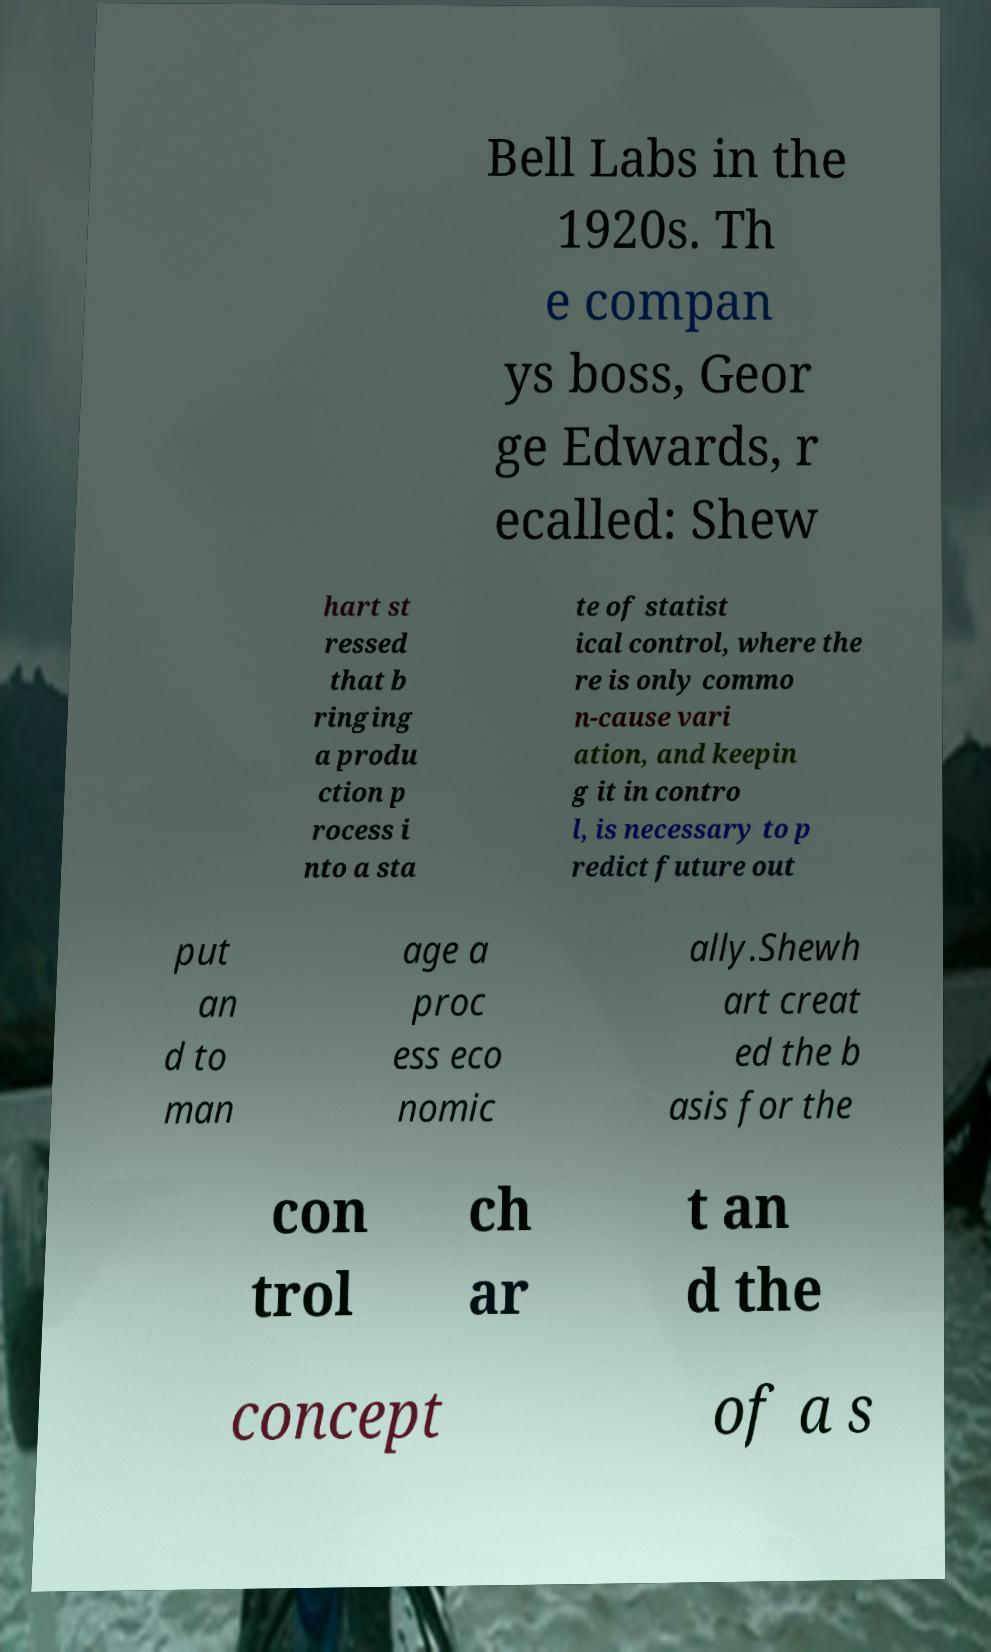Please read and relay the text visible in this image. What does it say? Bell Labs in the 1920s. Th e compan ys boss, Geor ge Edwards, r ecalled: Shew hart st ressed that b ringing a produ ction p rocess i nto a sta te of statist ical control, where the re is only commo n-cause vari ation, and keepin g it in contro l, is necessary to p redict future out put an d to man age a proc ess eco nomic ally.Shewh art creat ed the b asis for the con trol ch ar t an d the concept of a s 